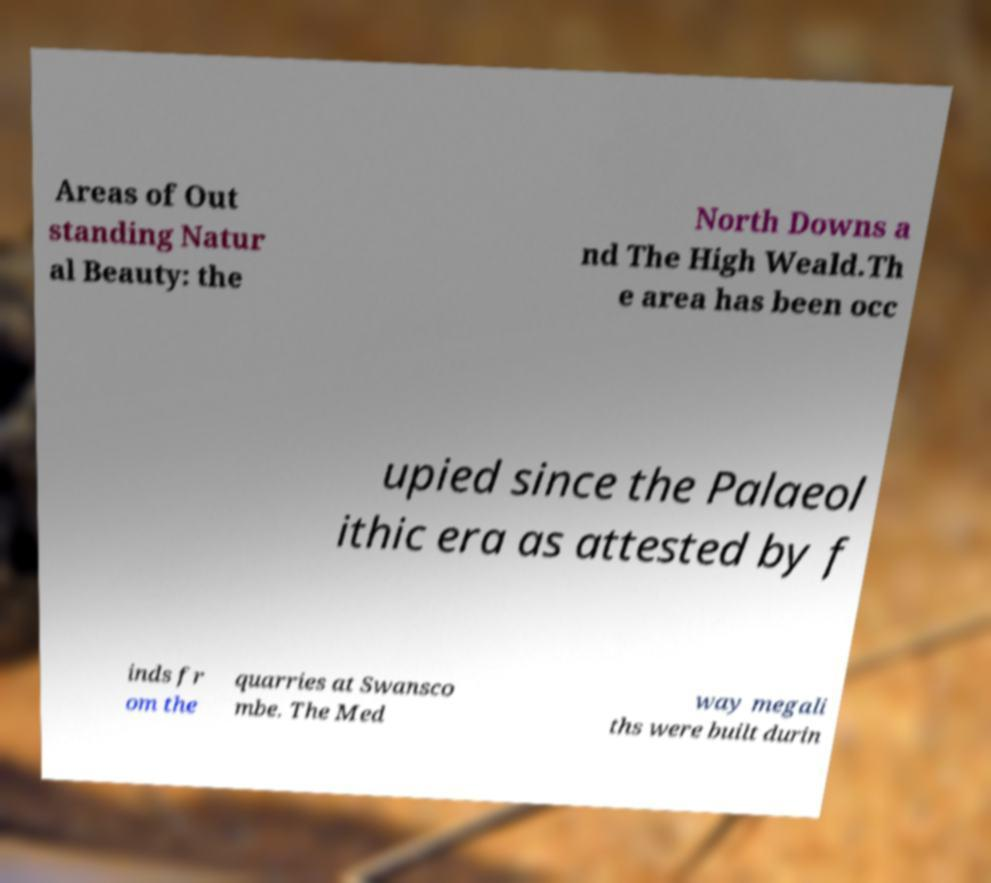Please identify and transcribe the text found in this image. Areas of Out standing Natur al Beauty: the North Downs a nd The High Weald.Th e area has been occ upied since the Palaeol ithic era as attested by f inds fr om the quarries at Swansco mbe. The Med way megali ths were built durin 